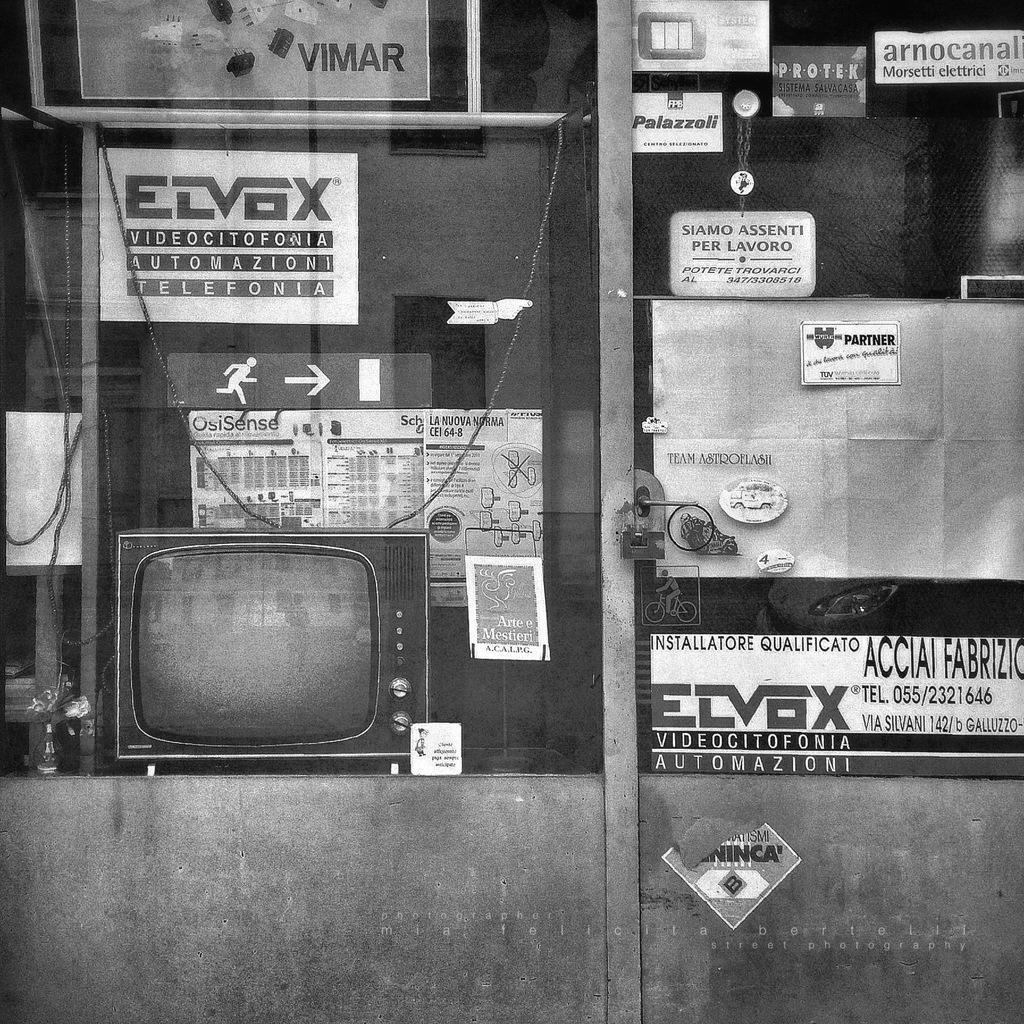What company is featured on the sign on the top left?
Provide a short and direct response. Vimar. 